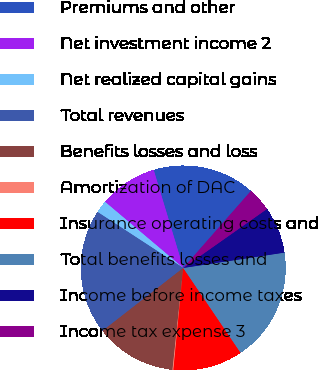Convert chart to OTSL. <chart><loc_0><loc_0><loc_500><loc_500><pie_chart><fcel>Premiums and other<fcel>Net investment income 2<fcel>Net realized capital gains<fcel>Total revenues<fcel>Benefits losses and loss<fcel>Amortization of DAC<fcel>Insurance operating costs and<fcel>Total benefits losses and<fcel>Income before income taxes<fcel>Income tax expense 3<nl><fcel>16.14%<fcel>9.17%<fcel>1.96%<fcel>19.74%<fcel>12.78%<fcel>0.16%<fcel>10.98%<fcel>17.94%<fcel>7.37%<fcel>3.76%<nl></chart> 